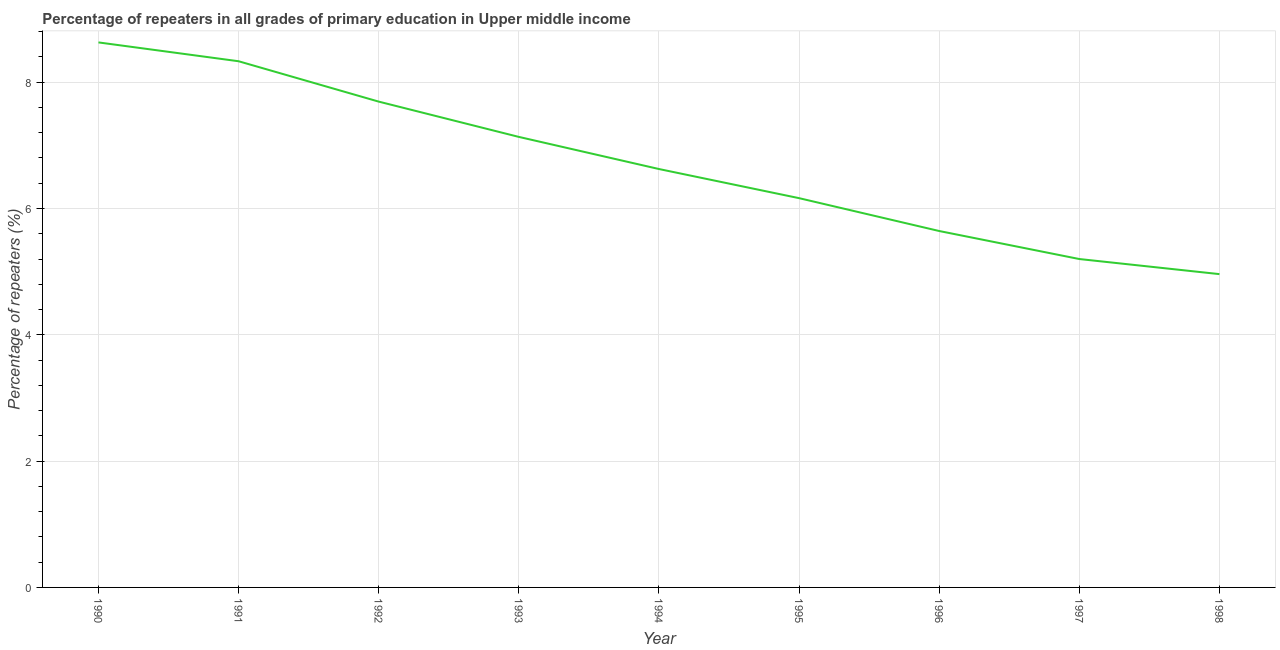What is the percentage of repeaters in primary education in 1992?
Make the answer very short. 7.69. Across all years, what is the maximum percentage of repeaters in primary education?
Ensure brevity in your answer.  8.63. Across all years, what is the minimum percentage of repeaters in primary education?
Your response must be concise. 4.96. In which year was the percentage of repeaters in primary education maximum?
Give a very brief answer. 1990. What is the sum of the percentage of repeaters in primary education?
Your answer should be very brief. 60.38. What is the difference between the percentage of repeaters in primary education in 1991 and 1994?
Your answer should be compact. 1.71. What is the average percentage of repeaters in primary education per year?
Provide a succinct answer. 6.71. What is the median percentage of repeaters in primary education?
Provide a short and direct response. 6.63. In how many years, is the percentage of repeaters in primary education greater than 5.6 %?
Make the answer very short. 7. What is the ratio of the percentage of repeaters in primary education in 1996 to that in 1997?
Ensure brevity in your answer.  1.09. What is the difference between the highest and the second highest percentage of repeaters in primary education?
Offer a terse response. 0.3. Is the sum of the percentage of repeaters in primary education in 1996 and 1998 greater than the maximum percentage of repeaters in primary education across all years?
Offer a very short reply. Yes. What is the difference between the highest and the lowest percentage of repeaters in primary education?
Make the answer very short. 3.67. In how many years, is the percentage of repeaters in primary education greater than the average percentage of repeaters in primary education taken over all years?
Your answer should be very brief. 4. How many lines are there?
Offer a very short reply. 1. How many years are there in the graph?
Provide a short and direct response. 9. Are the values on the major ticks of Y-axis written in scientific E-notation?
Ensure brevity in your answer.  No. Does the graph contain grids?
Offer a very short reply. Yes. What is the title of the graph?
Keep it short and to the point. Percentage of repeaters in all grades of primary education in Upper middle income. What is the label or title of the Y-axis?
Offer a terse response. Percentage of repeaters (%). What is the Percentage of repeaters (%) of 1990?
Ensure brevity in your answer.  8.63. What is the Percentage of repeaters (%) of 1991?
Offer a very short reply. 8.33. What is the Percentage of repeaters (%) of 1992?
Make the answer very short. 7.69. What is the Percentage of repeaters (%) of 1993?
Ensure brevity in your answer.  7.13. What is the Percentage of repeaters (%) in 1994?
Offer a very short reply. 6.63. What is the Percentage of repeaters (%) in 1995?
Offer a very short reply. 6.16. What is the Percentage of repeaters (%) in 1996?
Your answer should be very brief. 5.64. What is the Percentage of repeaters (%) of 1997?
Provide a short and direct response. 5.2. What is the Percentage of repeaters (%) in 1998?
Provide a succinct answer. 4.96. What is the difference between the Percentage of repeaters (%) in 1990 and 1991?
Ensure brevity in your answer.  0.3. What is the difference between the Percentage of repeaters (%) in 1990 and 1992?
Your answer should be very brief. 0.94. What is the difference between the Percentage of repeaters (%) in 1990 and 1993?
Make the answer very short. 1.5. What is the difference between the Percentage of repeaters (%) in 1990 and 1994?
Your response must be concise. 2. What is the difference between the Percentage of repeaters (%) in 1990 and 1995?
Ensure brevity in your answer.  2.47. What is the difference between the Percentage of repeaters (%) in 1990 and 1996?
Your answer should be very brief. 2.99. What is the difference between the Percentage of repeaters (%) in 1990 and 1997?
Ensure brevity in your answer.  3.43. What is the difference between the Percentage of repeaters (%) in 1990 and 1998?
Your answer should be very brief. 3.67. What is the difference between the Percentage of repeaters (%) in 1991 and 1992?
Keep it short and to the point. 0.64. What is the difference between the Percentage of repeaters (%) in 1991 and 1993?
Your answer should be very brief. 1.2. What is the difference between the Percentage of repeaters (%) in 1991 and 1994?
Provide a succinct answer. 1.71. What is the difference between the Percentage of repeaters (%) in 1991 and 1995?
Provide a succinct answer. 2.17. What is the difference between the Percentage of repeaters (%) in 1991 and 1996?
Offer a terse response. 2.69. What is the difference between the Percentage of repeaters (%) in 1991 and 1997?
Provide a succinct answer. 3.13. What is the difference between the Percentage of repeaters (%) in 1991 and 1998?
Your answer should be compact. 3.37. What is the difference between the Percentage of repeaters (%) in 1992 and 1993?
Ensure brevity in your answer.  0.56. What is the difference between the Percentage of repeaters (%) in 1992 and 1994?
Keep it short and to the point. 1.07. What is the difference between the Percentage of repeaters (%) in 1992 and 1995?
Offer a very short reply. 1.53. What is the difference between the Percentage of repeaters (%) in 1992 and 1996?
Provide a succinct answer. 2.05. What is the difference between the Percentage of repeaters (%) in 1992 and 1997?
Your answer should be compact. 2.49. What is the difference between the Percentage of repeaters (%) in 1992 and 1998?
Provide a succinct answer. 2.73. What is the difference between the Percentage of repeaters (%) in 1993 and 1994?
Provide a short and direct response. 0.51. What is the difference between the Percentage of repeaters (%) in 1993 and 1995?
Give a very brief answer. 0.97. What is the difference between the Percentage of repeaters (%) in 1993 and 1996?
Your answer should be very brief. 1.49. What is the difference between the Percentage of repeaters (%) in 1993 and 1997?
Give a very brief answer. 1.93. What is the difference between the Percentage of repeaters (%) in 1993 and 1998?
Give a very brief answer. 2.17. What is the difference between the Percentage of repeaters (%) in 1994 and 1995?
Provide a succinct answer. 0.46. What is the difference between the Percentage of repeaters (%) in 1994 and 1996?
Offer a terse response. 0.98. What is the difference between the Percentage of repeaters (%) in 1994 and 1997?
Your answer should be very brief. 1.43. What is the difference between the Percentage of repeaters (%) in 1994 and 1998?
Provide a short and direct response. 1.66. What is the difference between the Percentage of repeaters (%) in 1995 and 1996?
Offer a terse response. 0.52. What is the difference between the Percentage of repeaters (%) in 1995 and 1997?
Make the answer very short. 0.96. What is the difference between the Percentage of repeaters (%) in 1995 and 1998?
Ensure brevity in your answer.  1.2. What is the difference between the Percentage of repeaters (%) in 1996 and 1997?
Ensure brevity in your answer.  0.44. What is the difference between the Percentage of repeaters (%) in 1996 and 1998?
Offer a terse response. 0.68. What is the difference between the Percentage of repeaters (%) in 1997 and 1998?
Provide a succinct answer. 0.24. What is the ratio of the Percentage of repeaters (%) in 1990 to that in 1991?
Your response must be concise. 1.04. What is the ratio of the Percentage of repeaters (%) in 1990 to that in 1992?
Your response must be concise. 1.12. What is the ratio of the Percentage of repeaters (%) in 1990 to that in 1993?
Your answer should be compact. 1.21. What is the ratio of the Percentage of repeaters (%) in 1990 to that in 1994?
Offer a very short reply. 1.3. What is the ratio of the Percentage of repeaters (%) in 1990 to that in 1995?
Provide a succinct answer. 1.4. What is the ratio of the Percentage of repeaters (%) in 1990 to that in 1996?
Your answer should be very brief. 1.53. What is the ratio of the Percentage of repeaters (%) in 1990 to that in 1997?
Your answer should be compact. 1.66. What is the ratio of the Percentage of repeaters (%) in 1990 to that in 1998?
Keep it short and to the point. 1.74. What is the ratio of the Percentage of repeaters (%) in 1991 to that in 1992?
Make the answer very short. 1.08. What is the ratio of the Percentage of repeaters (%) in 1991 to that in 1993?
Offer a very short reply. 1.17. What is the ratio of the Percentage of repeaters (%) in 1991 to that in 1994?
Provide a short and direct response. 1.26. What is the ratio of the Percentage of repeaters (%) in 1991 to that in 1995?
Keep it short and to the point. 1.35. What is the ratio of the Percentage of repeaters (%) in 1991 to that in 1996?
Ensure brevity in your answer.  1.48. What is the ratio of the Percentage of repeaters (%) in 1991 to that in 1997?
Your answer should be very brief. 1.6. What is the ratio of the Percentage of repeaters (%) in 1991 to that in 1998?
Offer a terse response. 1.68. What is the ratio of the Percentage of repeaters (%) in 1992 to that in 1993?
Your answer should be very brief. 1.08. What is the ratio of the Percentage of repeaters (%) in 1992 to that in 1994?
Give a very brief answer. 1.16. What is the ratio of the Percentage of repeaters (%) in 1992 to that in 1995?
Keep it short and to the point. 1.25. What is the ratio of the Percentage of repeaters (%) in 1992 to that in 1996?
Provide a short and direct response. 1.36. What is the ratio of the Percentage of repeaters (%) in 1992 to that in 1997?
Provide a succinct answer. 1.48. What is the ratio of the Percentage of repeaters (%) in 1992 to that in 1998?
Offer a very short reply. 1.55. What is the ratio of the Percentage of repeaters (%) in 1993 to that in 1994?
Offer a terse response. 1.08. What is the ratio of the Percentage of repeaters (%) in 1993 to that in 1995?
Your answer should be compact. 1.16. What is the ratio of the Percentage of repeaters (%) in 1993 to that in 1996?
Give a very brief answer. 1.26. What is the ratio of the Percentage of repeaters (%) in 1993 to that in 1997?
Your response must be concise. 1.37. What is the ratio of the Percentage of repeaters (%) in 1993 to that in 1998?
Offer a very short reply. 1.44. What is the ratio of the Percentage of repeaters (%) in 1994 to that in 1995?
Your response must be concise. 1.07. What is the ratio of the Percentage of repeaters (%) in 1994 to that in 1996?
Provide a succinct answer. 1.17. What is the ratio of the Percentage of repeaters (%) in 1994 to that in 1997?
Make the answer very short. 1.27. What is the ratio of the Percentage of repeaters (%) in 1994 to that in 1998?
Your answer should be very brief. 1.33. What is the ratio of the Percentage of repeaters (%) in 1995 to that in 1996?
Your answer should be very brief. 1.09. What is the ratio of the Percentage of repeaters (%) in 1995 to that in 1997?
Your response must be concise. 1.19. What is the ratio of the Percentage of repeaters (%) in 1995 to that in 1998?
Make the answer very short. 1.24. What is the ratio of the Percentage of repeaters (%) in 1996 to that in 1997?
Your answer should be compact. 1.08. What is the ratio of the Percentage of repeaters (%) in 1996 to that in 1998?
Provide a short and direct response. 1.14. What is the ratio of the Percentage of repeaters (%) in 1997 to that in 1998?
Your answer should be very brief. 1.05. 